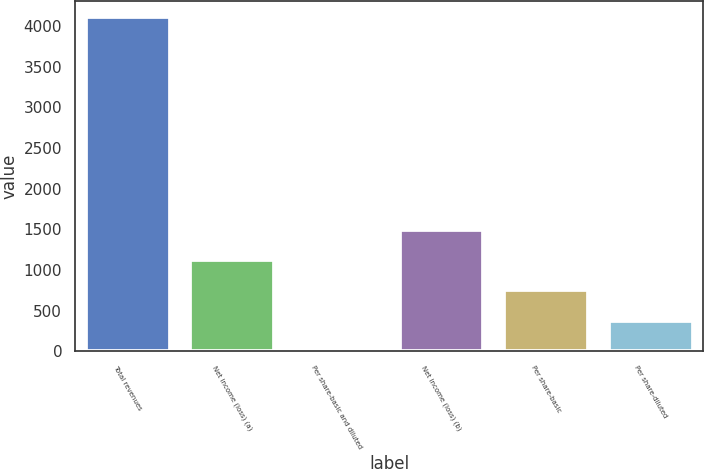Convert chart to OTSL. <chart><loc_0><loc_0><loc_500><loc_500><bar_chart><fcel>Total revenues<fcel>Net income (loss) (a)<fcel>Per share-basic and diluted<fcel>Net income (loss) (b)<fcel>Per share-basic<fcel>Per share-diluted<nl><fcel>4108.34<fcel>1123.64<fcel>0.62<fcel>1497.98<fcel>749.3<fcel>374.96<nl></chart> 